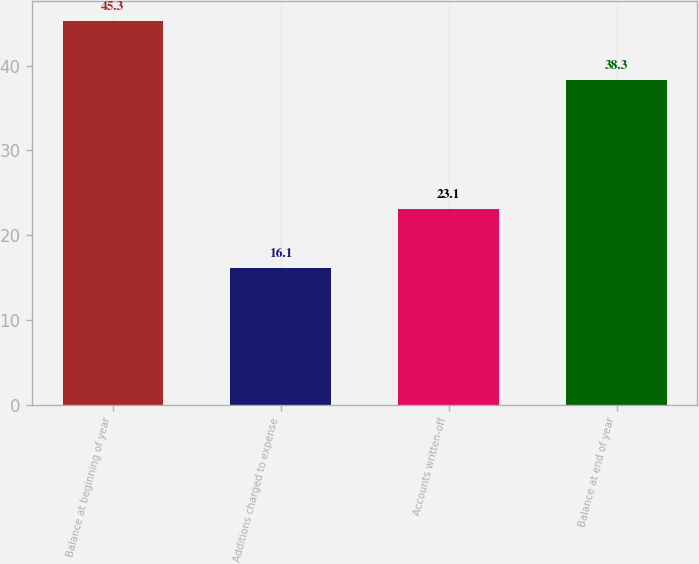<chart> <loc_0><loc_0><loc_500><loc_500><bar_chart><fcel>Balance at beginning of year<fcel>Additions charged to expense<fcel>Accounts written-off<fcel>Balance at end of year<nl><fcel>45.3<fcel>16.1<fcel>23.1<fcel>38.3<nl></chart> 